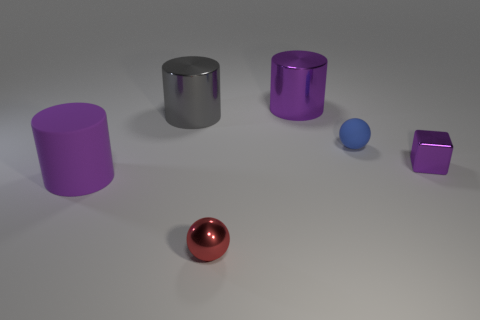There is a purple metallic thing that is the same shape as the large purple matte thing; what is its size?
Ensure brevity in your answer.  Large. What is the large gray object made of?
Provide a short and direct response. Metal. Are the small ball in front of the rubber cylinder and the big gray cylinder made of the same material?
Offer a very short reply. Yes. There is a purple thing that is to the left of the purple shiny block and on the right side of the gray cylinder; what size is it?
Your response must be concise. Large. How big is the matte object that is on the left side of the metal ball?
Offer a terse response. Large. The small metallic object that is the same color as the matte cylinder is what shape?
Make the answer very short. Cube. There is a matte object that is on the left side of the big metallic thing that is to the left of the purple cylinder behind the small purple metal cube; what is its shape?
Your answer should be compact. Cylinder. How many other objects are the same shape as the purple rubber thing?
Offer a very short reply. 2. How many shiny things are purple blocks or red objects?
Give a very brief answer. 2. The ball left of the sphere behind the tiny block is made of what material?
Make the answer very short. Metal. 